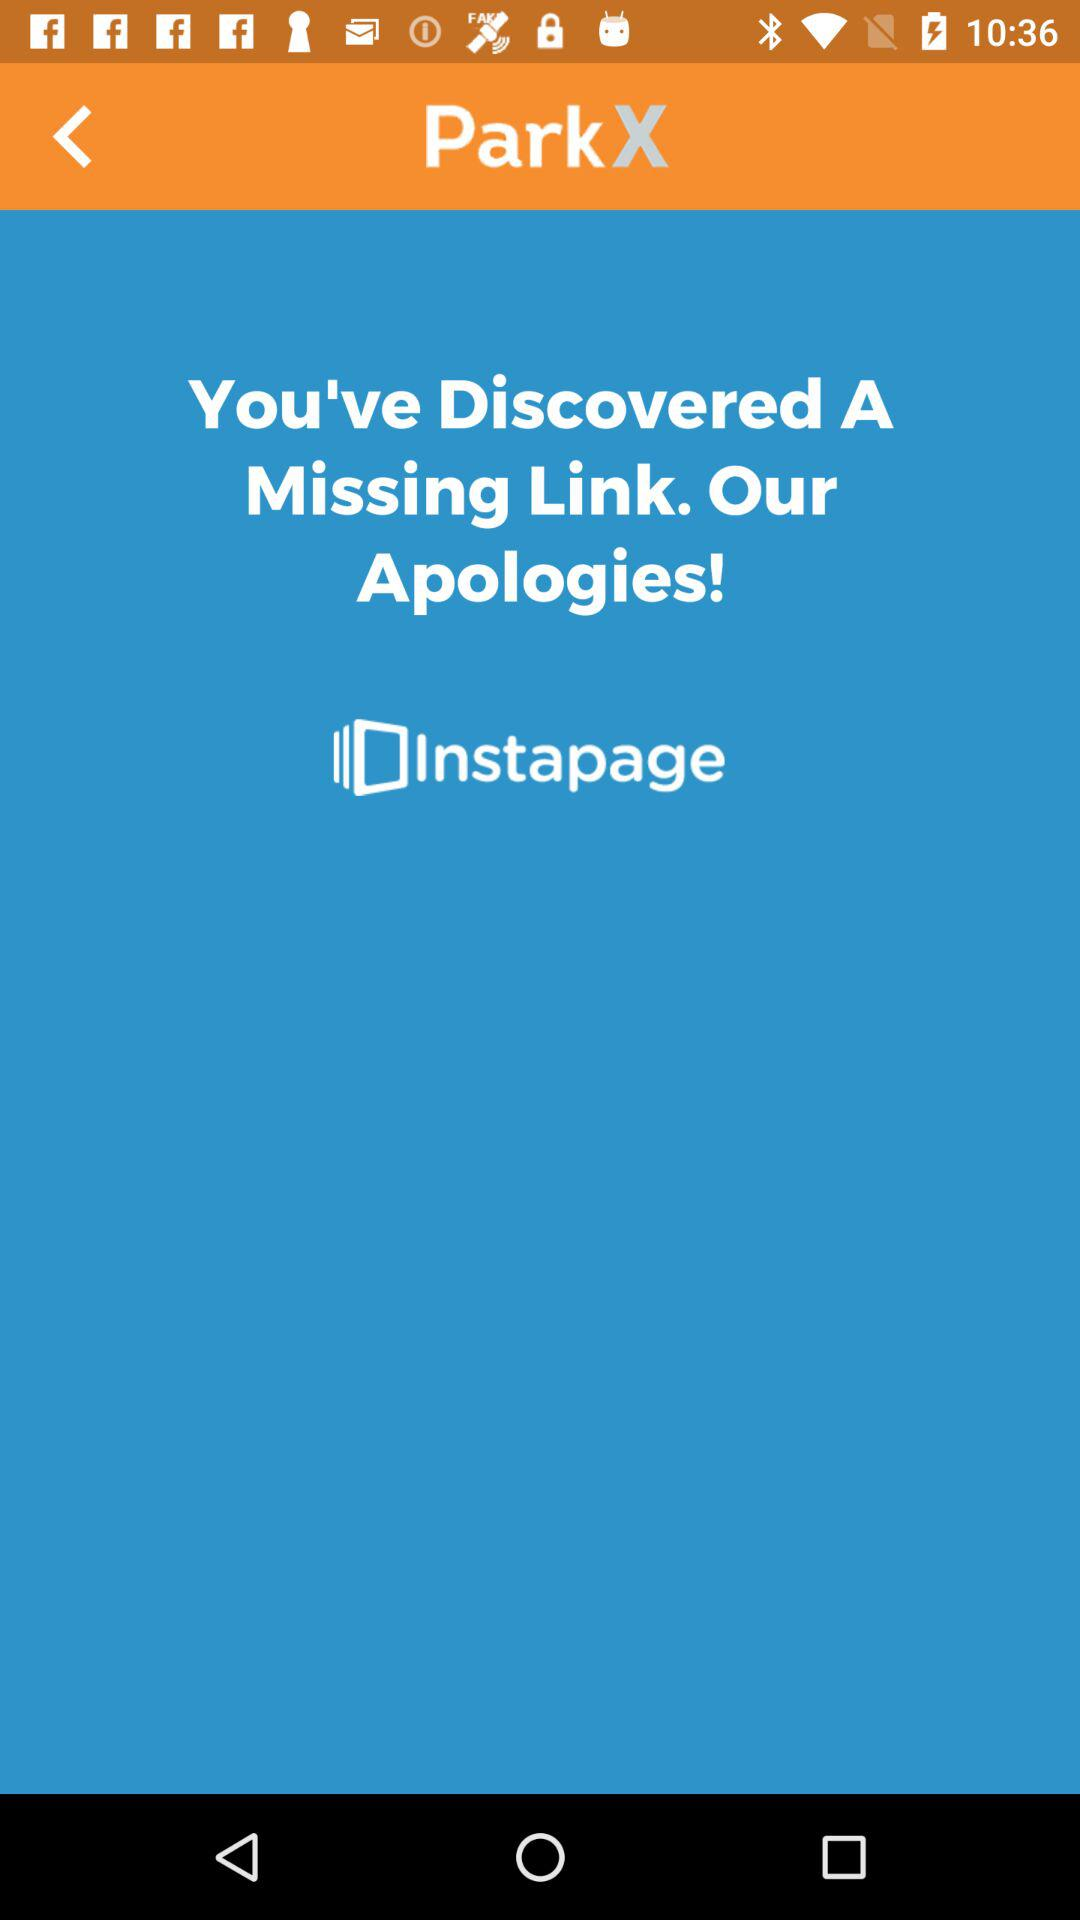Which version of the application is this?
When the provided information is insufficient, respond with <no answer>. <no answer> 